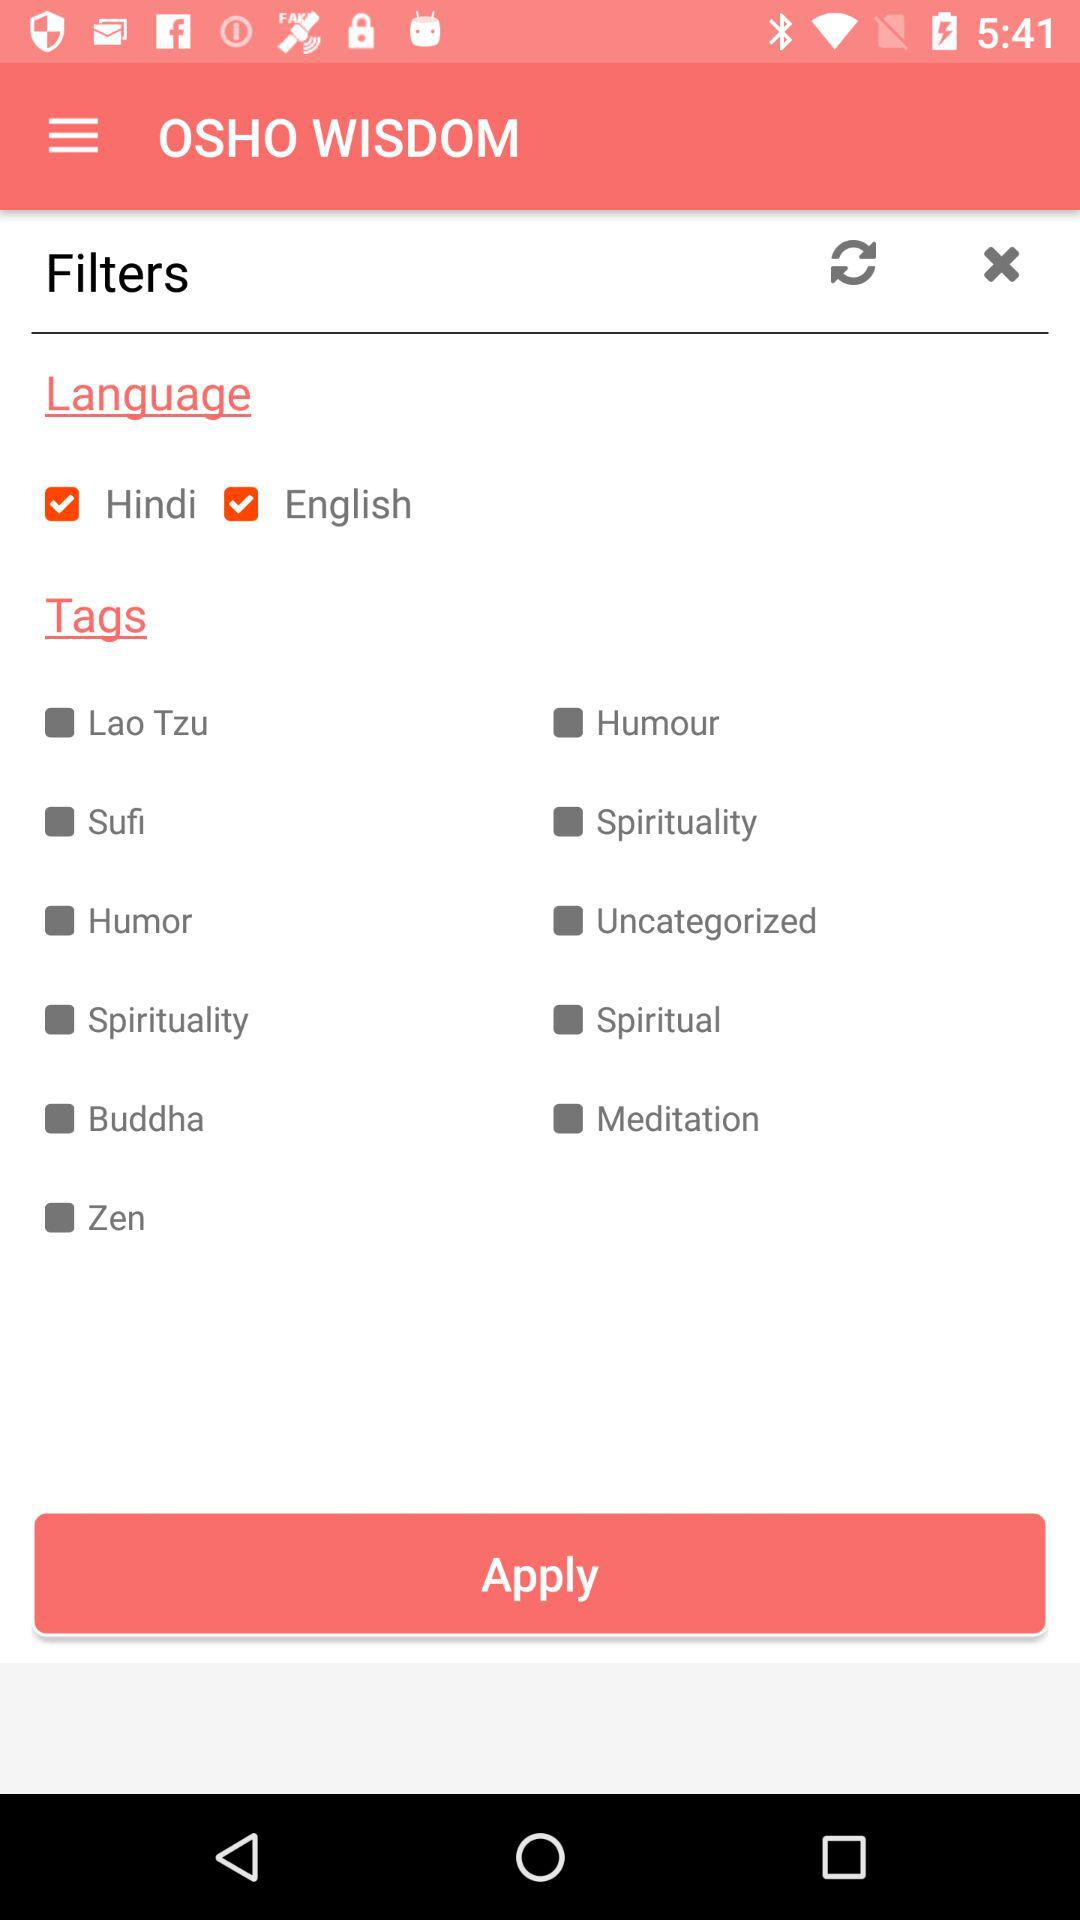Is "Hindi" language selected or not?
Answer the question using a single word or phrase. It is selected. 